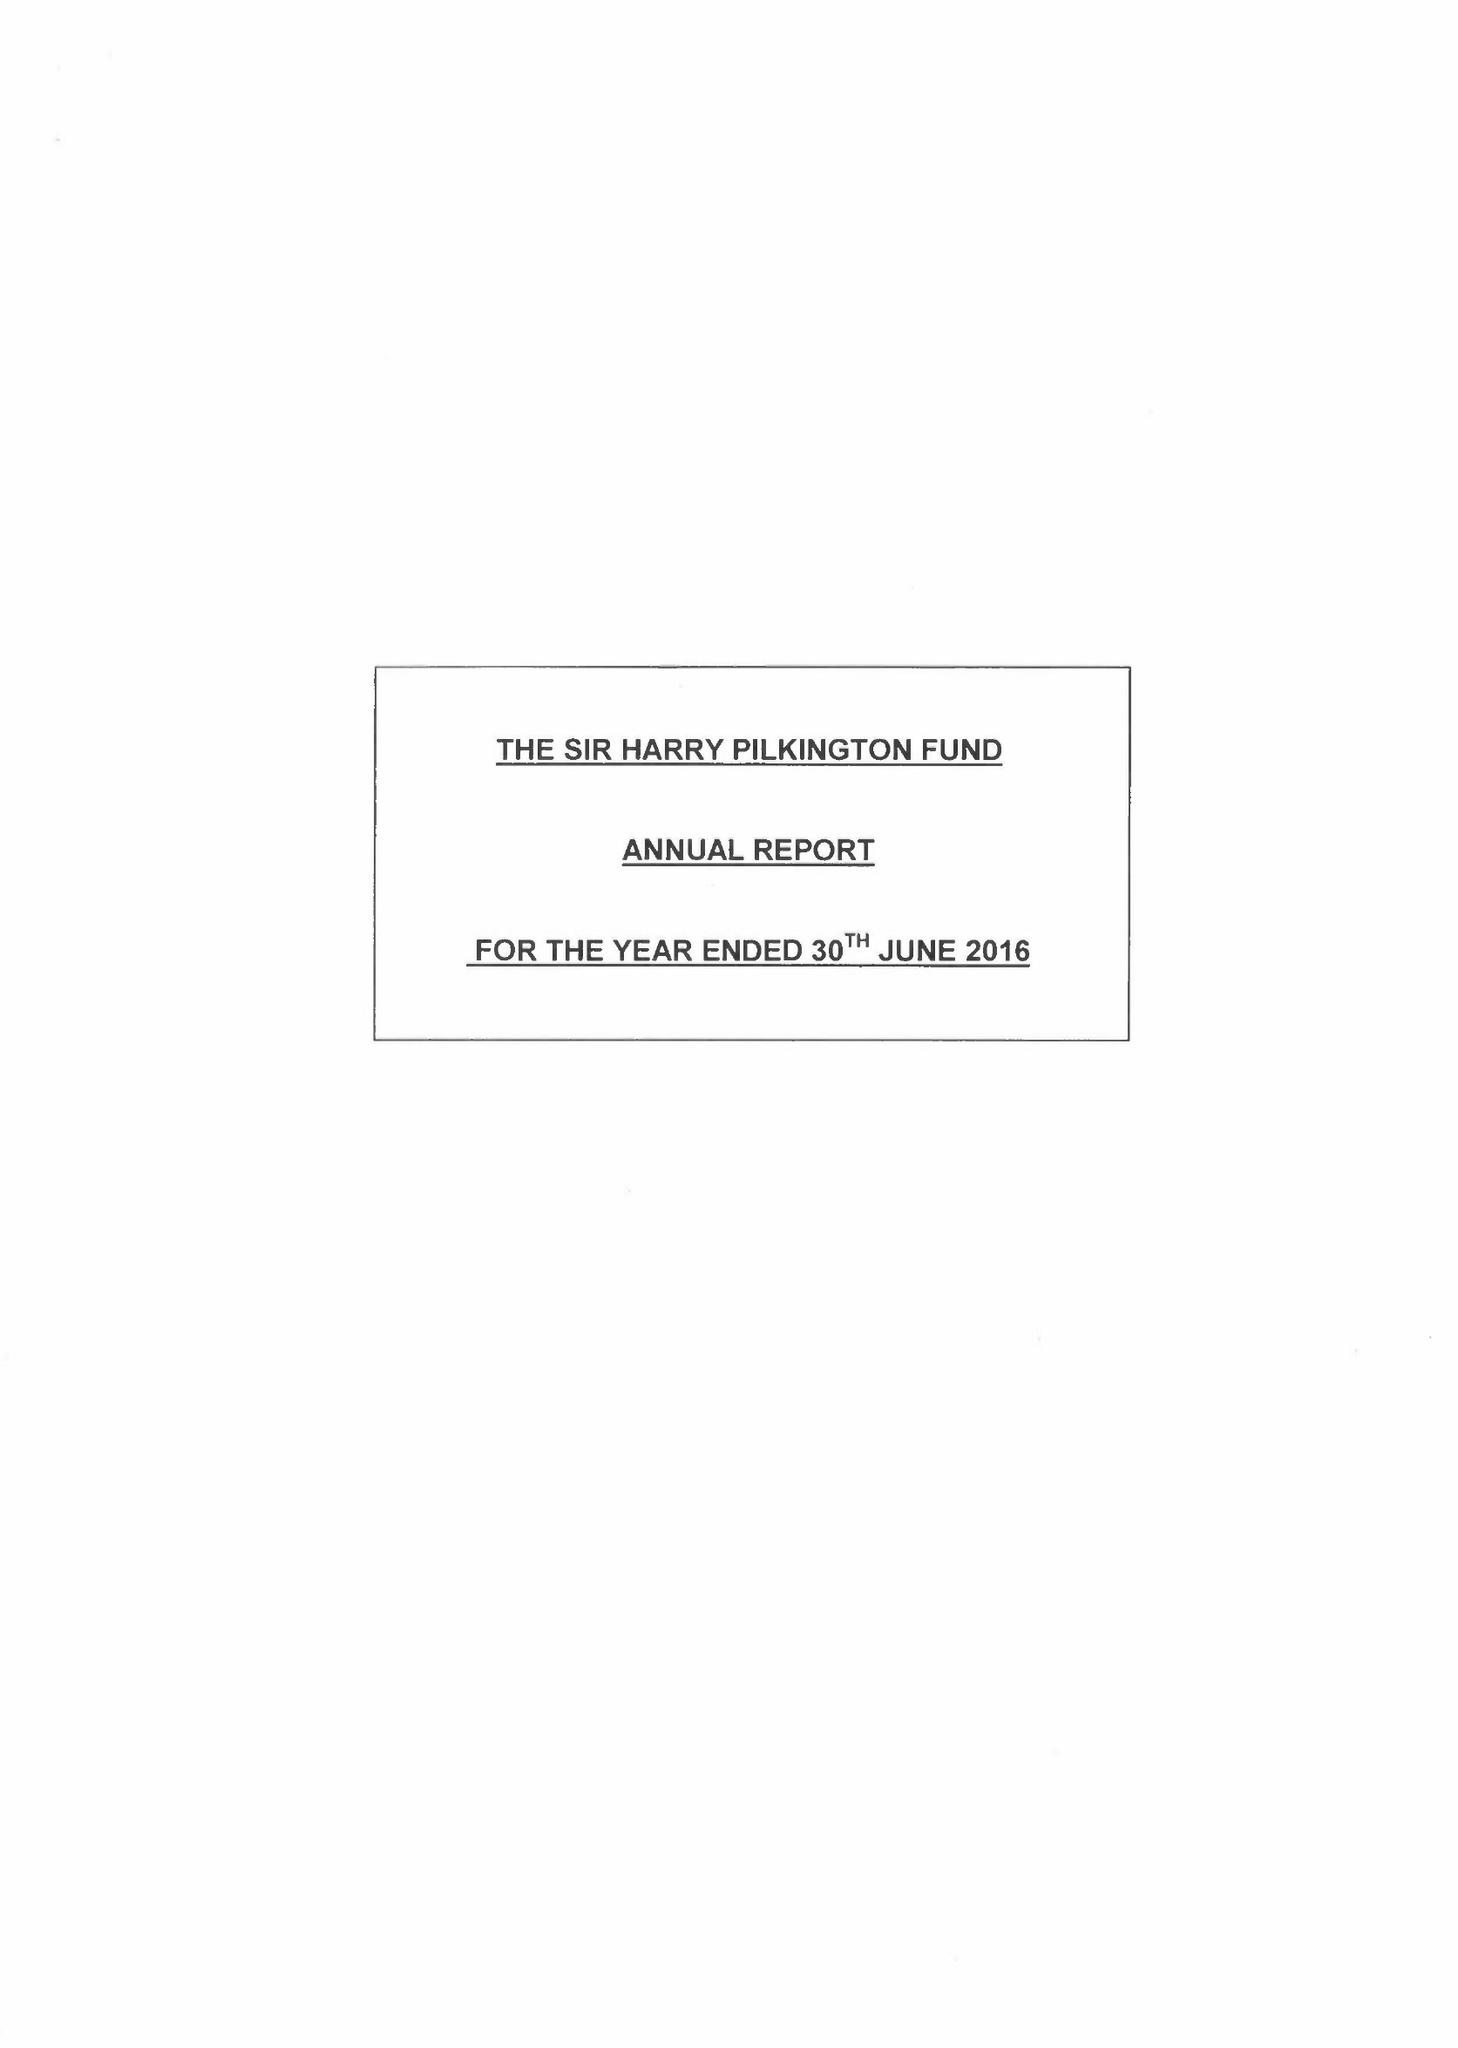What is the value for the spending_annually_in_british_pounds?
Answer the question using a single word or phrase. 130166.00 